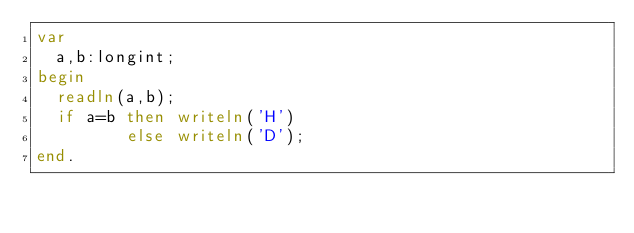<code> <loc_0><loc_0><loc_500><loc_500><_Pascal_>var
  a,b:longint;
begin
  readln(a,b);
  if a=b then writeln('H')
         else writeln('D');
end.</code> 